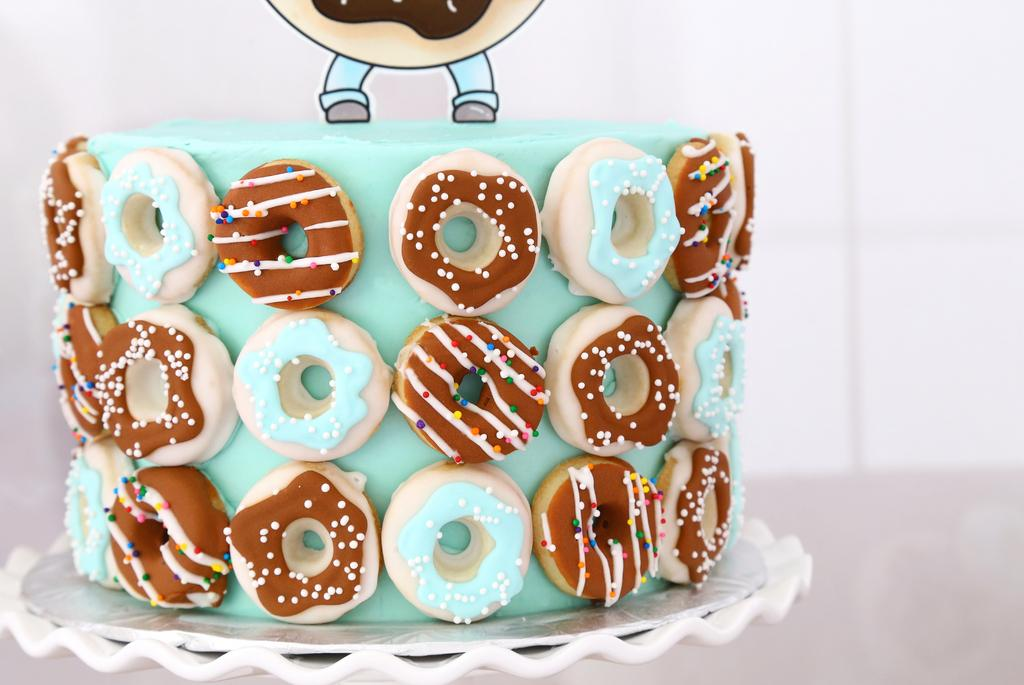What is the main subject of the image? There is a cake in the image. Can you describe the appearance of the cake? The cake is colorful. What is the cake placed on in the image? The cake is on a white object. What color is the background of the image? The background of the image is white. Can you tell me how many moms are in the image? There is no mom present in the image; it features a cake on a white object with a white background. What type of chin is visible on the cake in the image? There is no chin present in the image, as it features a cake and not a person. 